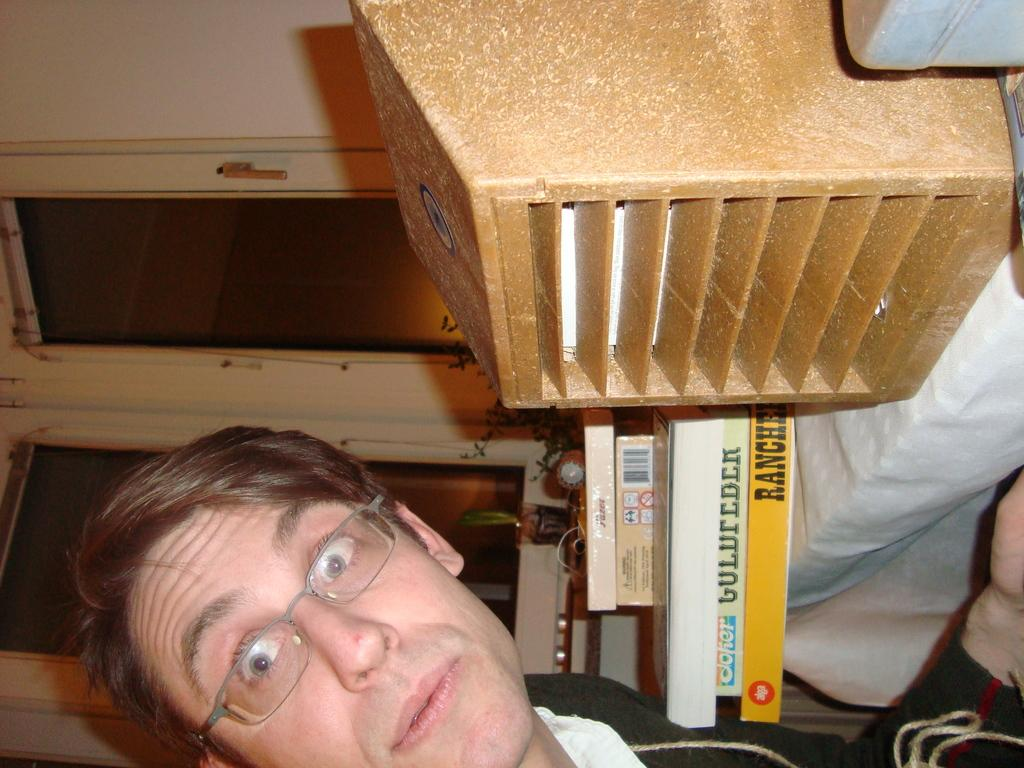Who is present in the image? There is a man in the image. What is the man doing in the image? The man is looking at his side. What accessory is the man wearing in the image? The man is wearing spectacles. What can be seen on the desk in the image? There are books on a desk in the image. What type of windows are visible in the image? There are glass windows in the image. What type of coach is the man driving in the image? There is no coach present in the image; it features a man looking at his side while wearing spectacles and standing near a desk with books and glass windows. 